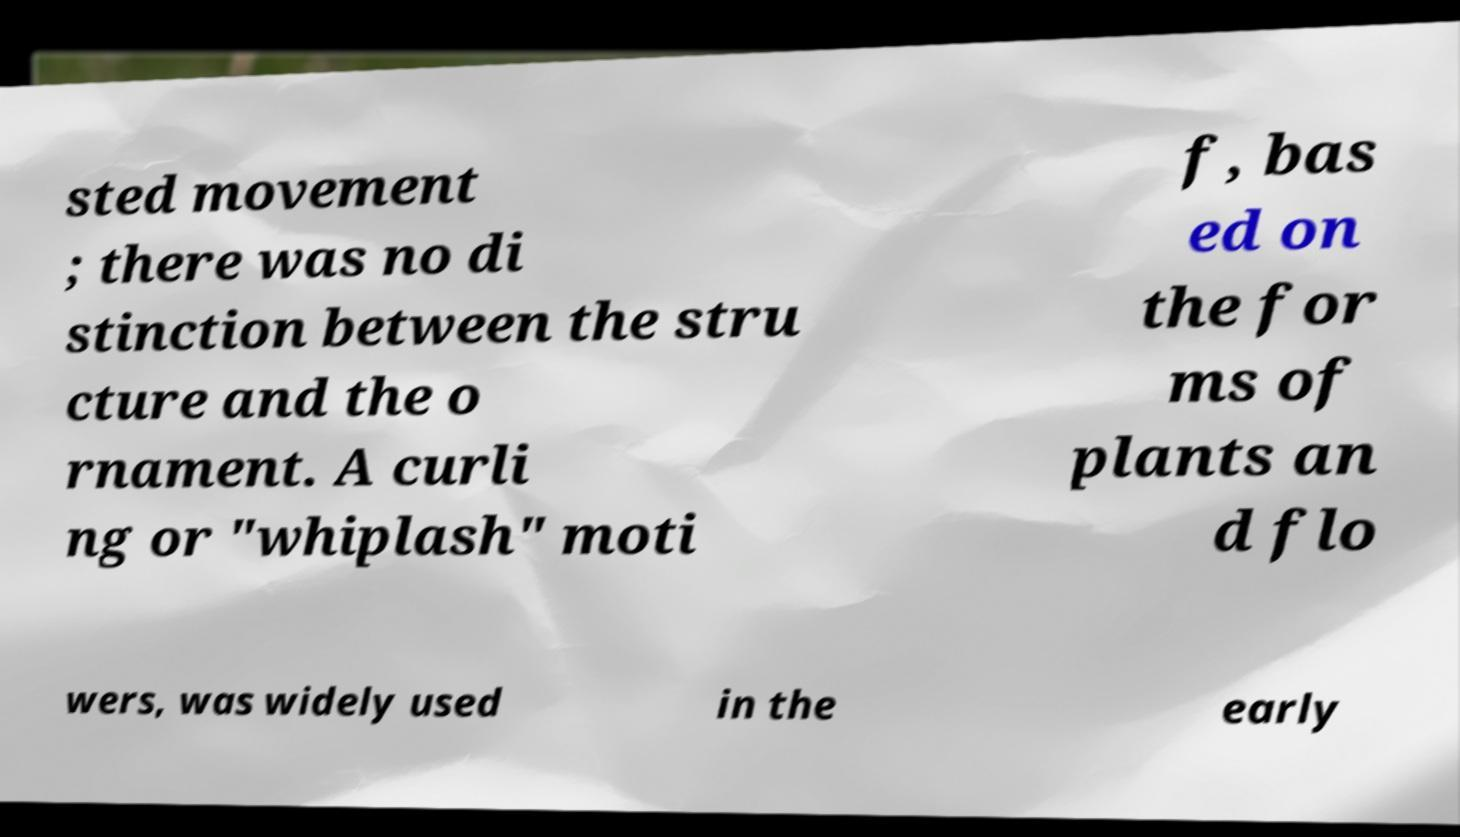Can you read and provide the text displayed in the image?This photo seems to have some interesting text. Can you extract and type it out for me? sted movement ; there was no di stinction between the stru cture and the o rnament. A curli ng or "whiplash" moti f, bas ed on the for ms of plants an d flo wers, was widely used in the early 